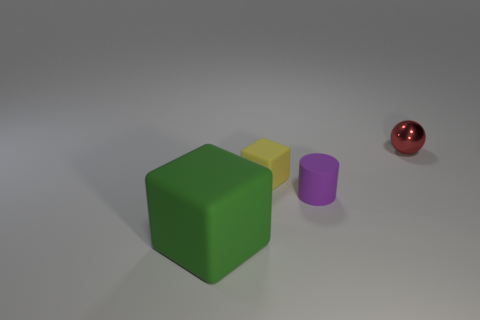Is there any other thing that is the same size as the green object?
Keep it short and to the point. No. Are there any other things that have the same material as the red thing?
Your answer should be very brief. No. There is a yellow block that is the same size as the red thing; what is its material?
Make the answer very short. Rubber. There is a block that is behind the purple cylinder; is its size the same as the thing in front of the small cylinder?
Your answer should be very brief. No. Is there another small red ball made of the same material as the tiny sphere?
Keep it short and to the point. No. What number of things are either matte cubes to the right of the large object or tiny metal cylinders?
Offer a terse response. 1. Is the material of the thing in front of the tiny purple cylinder the same as the tiny purple object?
Your response must be concise. Yes. Does the big green thing have the same shape as the yellow rubber object?
Your answer should be very brief. Yes. There is a thing that is on the right side of the purple rubber thing; what number of tiny rubber objects are left of it?
Provide a short and direct response. 2. There is another object that is the same shape as the large green object; what is its material?
Ensure brevity in your answer.  Rubber. 